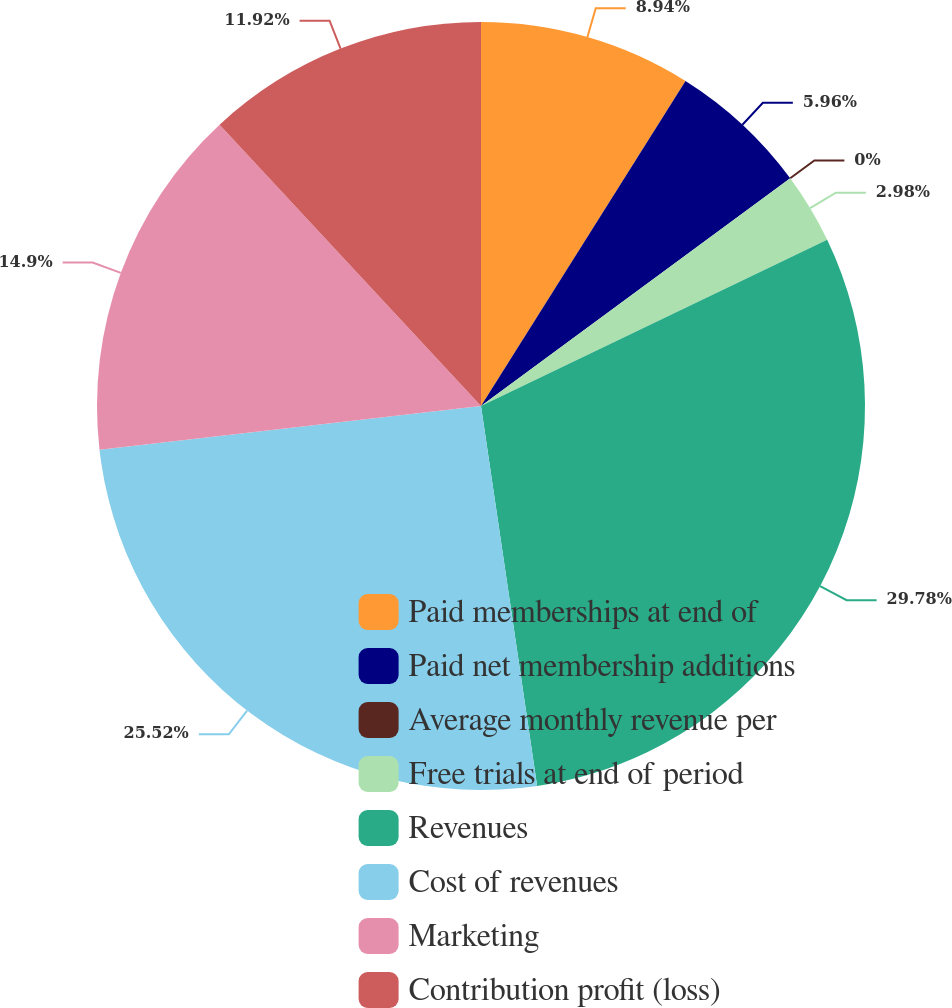<chart> <loc_0><loc_0><loc_500><loc_500><pie_chart><fcel>Paid memberships at end of<fcel>Paid net membership additions<fcel>Average monthly revenue per<fcel>Free trials at end of period<fcel>Revenues<fcel>Cost of revenues<fcel>Marketing<fcel>Contribution profit (loss)<nl><fcel>8.94%<fcel>5.96%<fcel>0.0%<fcel>2.98%<fcel>29.79%<fcel>25.52%<fcel>14.9%<fcel>11.92%<nl></chart> 